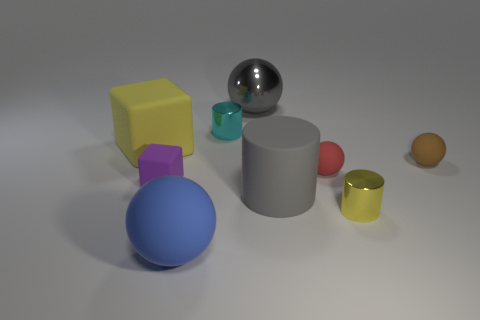Subtract 1 balls. How many balls are left? 3 Add 1 red matte balls. How many objects exist? 10 Subtract all cylinders. How many objects are left? 6 Subtract all large brown matte blocks. Subtract all blue matte spheres. How many objects are left? 8 Add 1 large metal balls. How many large metal balls are left? 2 Add 8 large yellow rubber blocks. How many large yellow rubber blocks exist? 9 Subtract 1 gray cylinders. How many objects are left? 8 